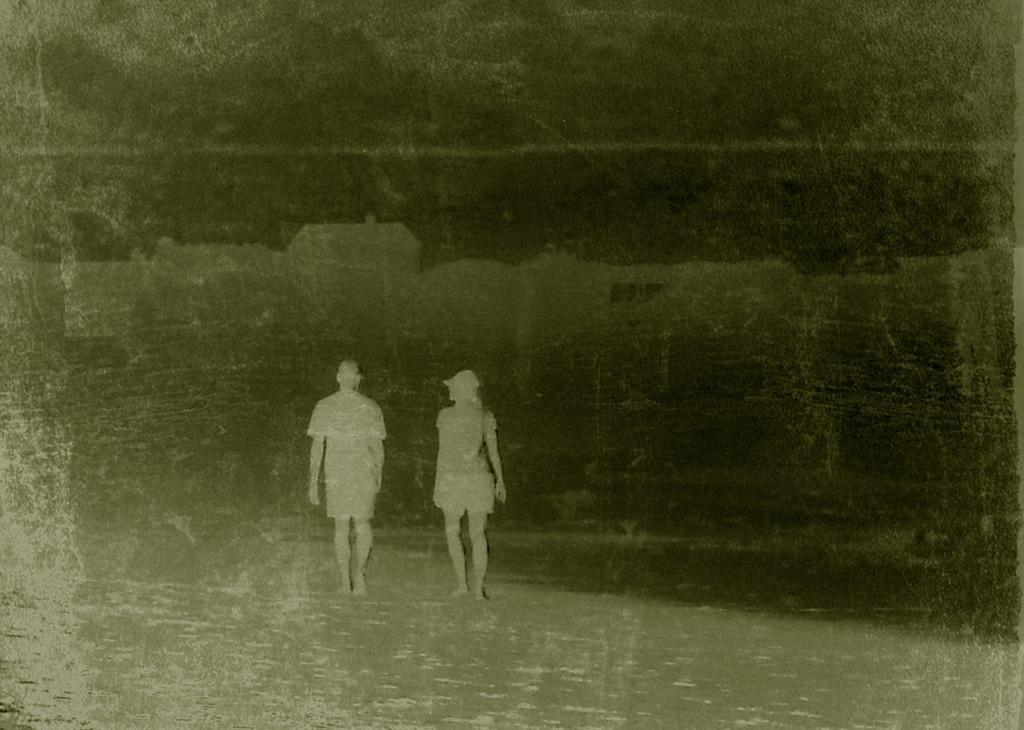Please provide a concise description of this image. This is a black and white photo and here we can see people. 